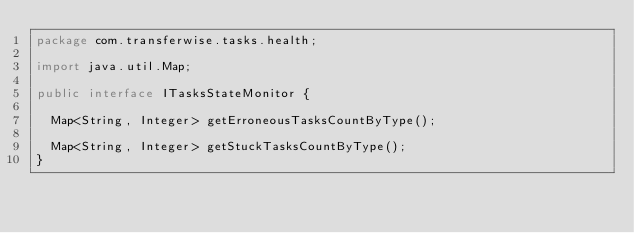<code> <loc_0><loc_0><loc_500><loc_500><_Java_>package com.transferwise.tasks.health;

import java.util.Map;

public interface ITasksStateMonitor {

  Map<String, Integer> getErroneousTasksCountByType();

  Map<String, Integer> getStuckTasksCountByType();
}
</code> 